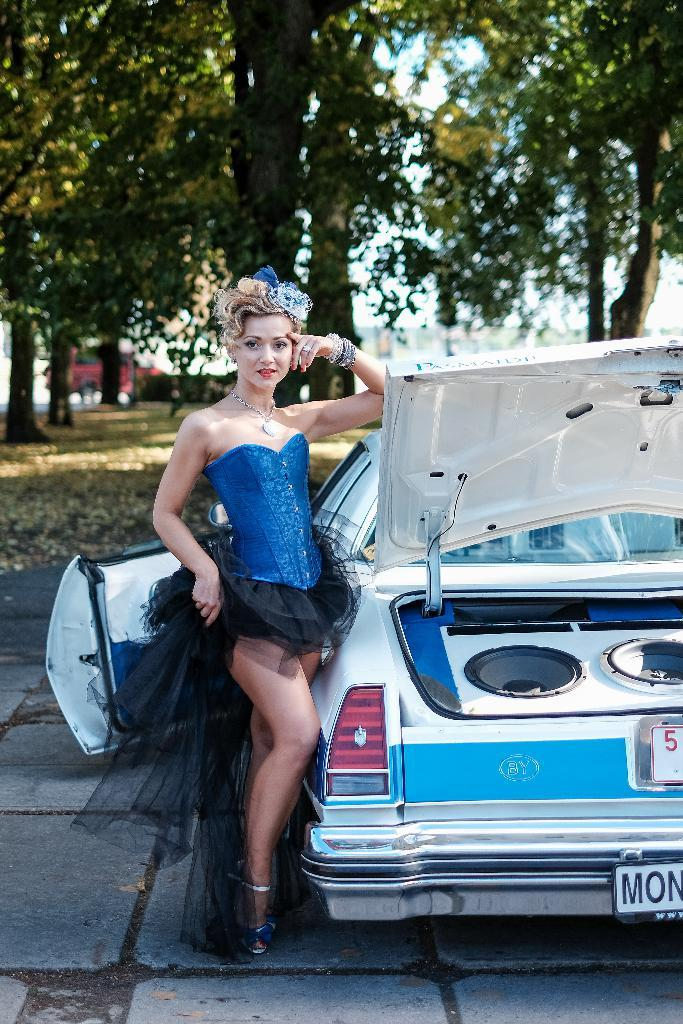What is happening in the image? There is a person standing beside a vehicle in the image. Can you describe the person's clothing? The person is wearing a blue and black color dress. What can be seen in the background of the image? There are many trees and the sky visible in the background of the image. What type of pin is the person holding in the image? There is no pin visible in the image. What class is the person attending in the image? There is no indication of a class or educational setting in the image. 